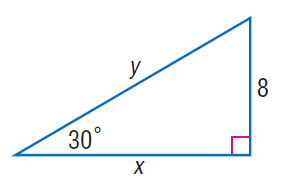Answer the mathemtical geometry problem and directly provide the correct option letter.
Question: Find y.
Choices: A: 8 B: 8 \sqrt { 3 } C: 16 D: 16 \sqrt { 3 } C 